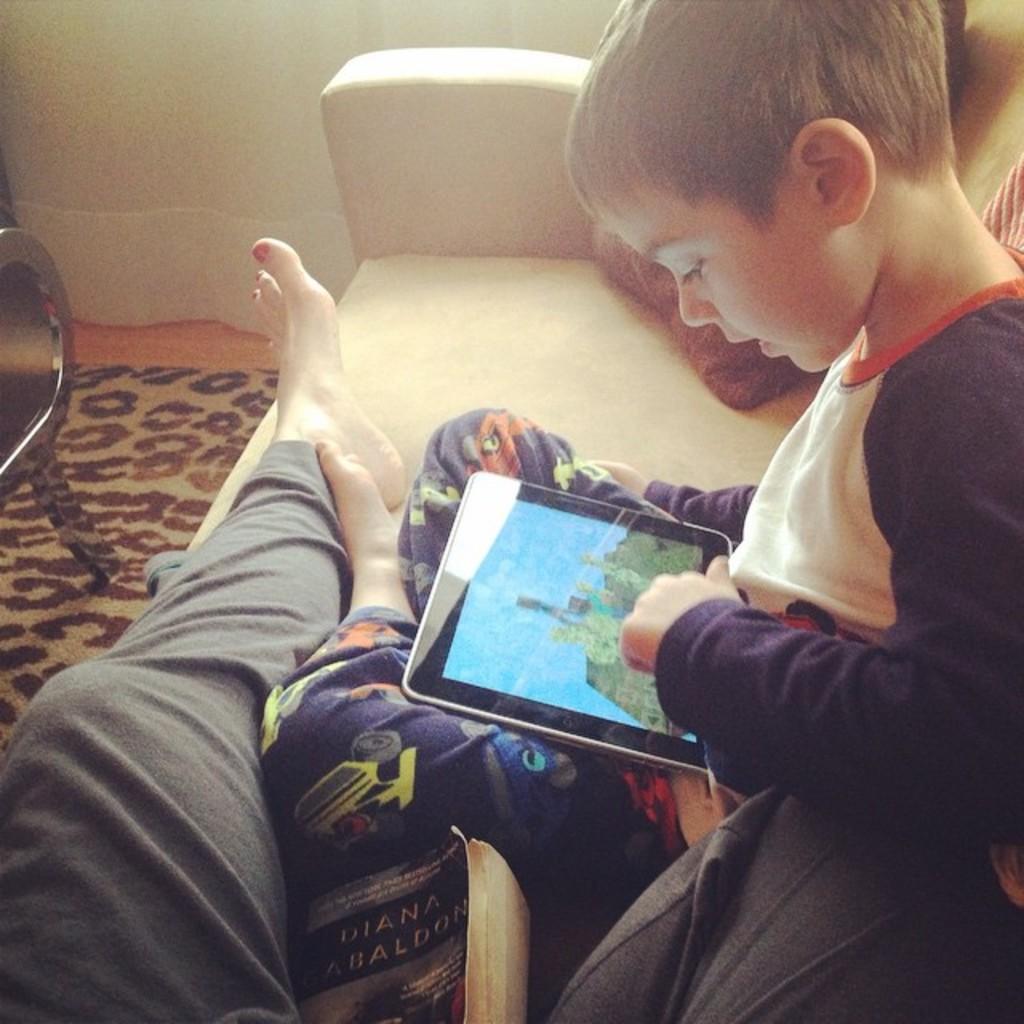Could you give a brief overview of what you see in this image? In this image we can see a boy is sitting on a couch and playing video game in an electronic gadget. A person is lying on a couch. There is a book, a chair, a curtain in the image. 